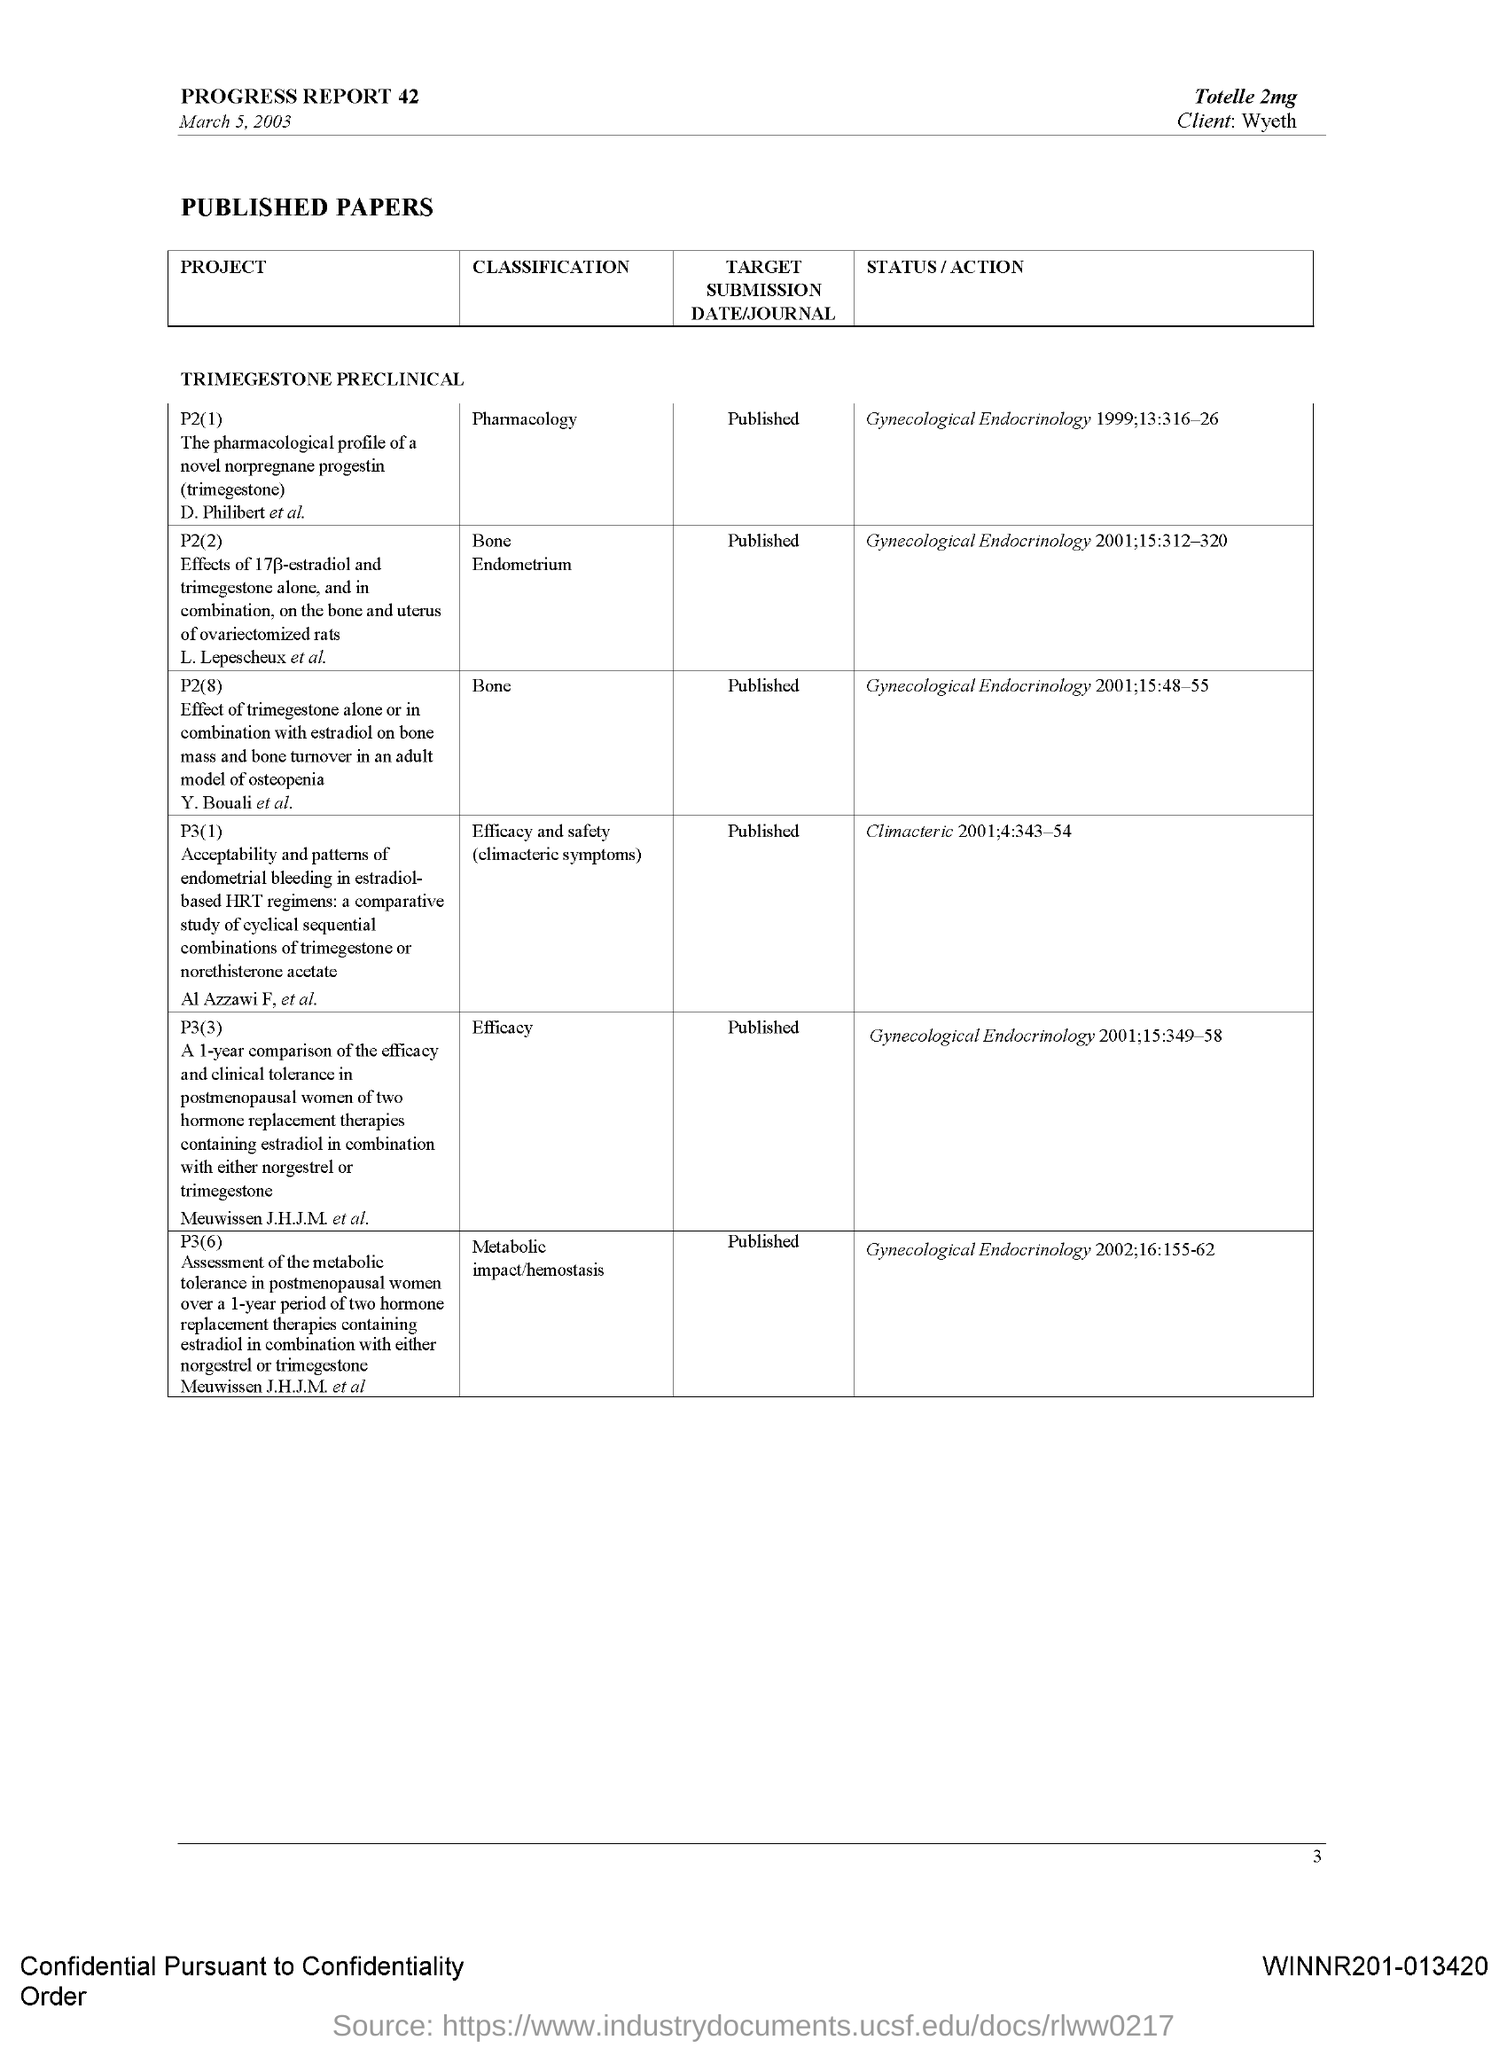Who is the client mentioned?
Make the answer very short. Wyeth. Which drug is mentioned?
Your answer should be compact. Totelle 2mg. When is the progress report dated?
Provide a succinct answer. March 5, 2003. What is the project P2(1)?
Keep it short and to the point. The pharmacological profile of a novel norpregnane progestin (trimegestone). What is the classification of the project P2(8)?
Your answer should be very brief. Bone. What is the target submission date/journal for project P3(6)?
Keep it short and to the point. Published. 